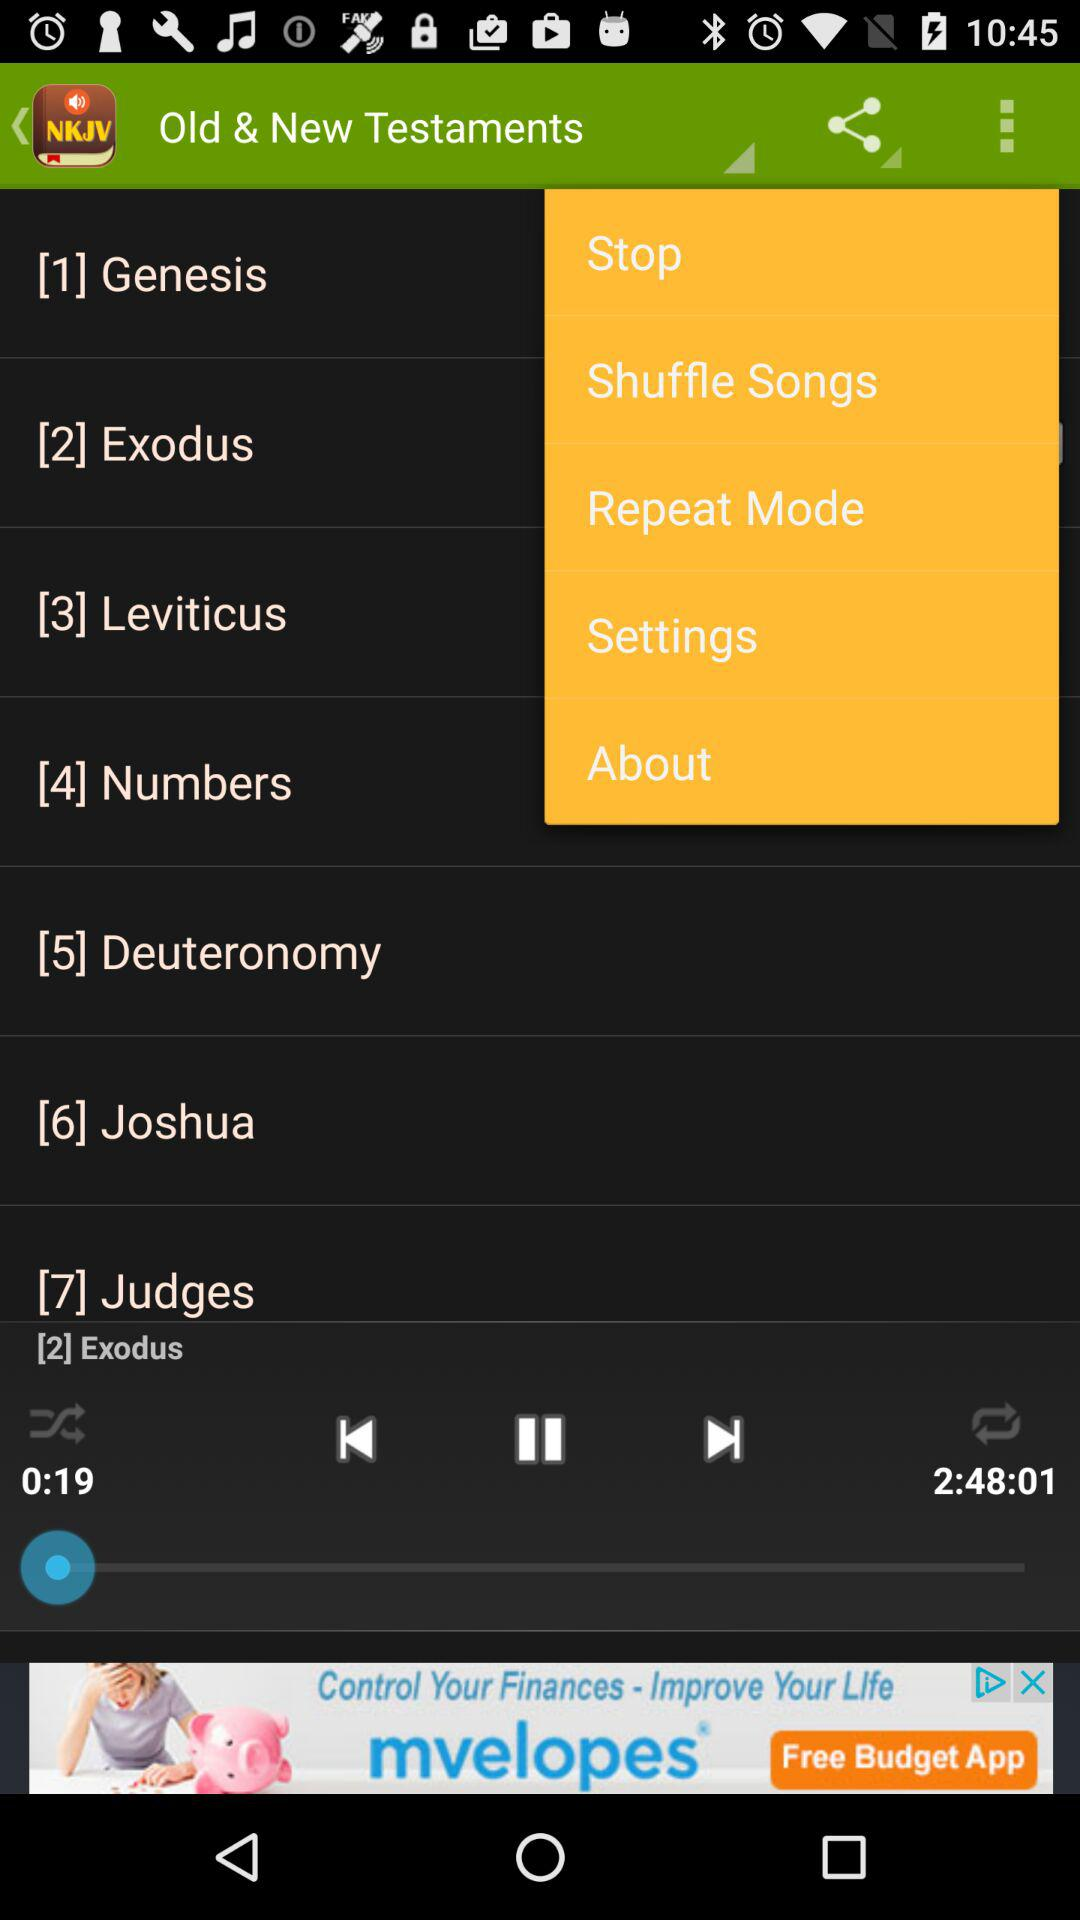What is the duration of the audio book? The duration of the audio book is 2 hours, 48 minutes and 1 second. 